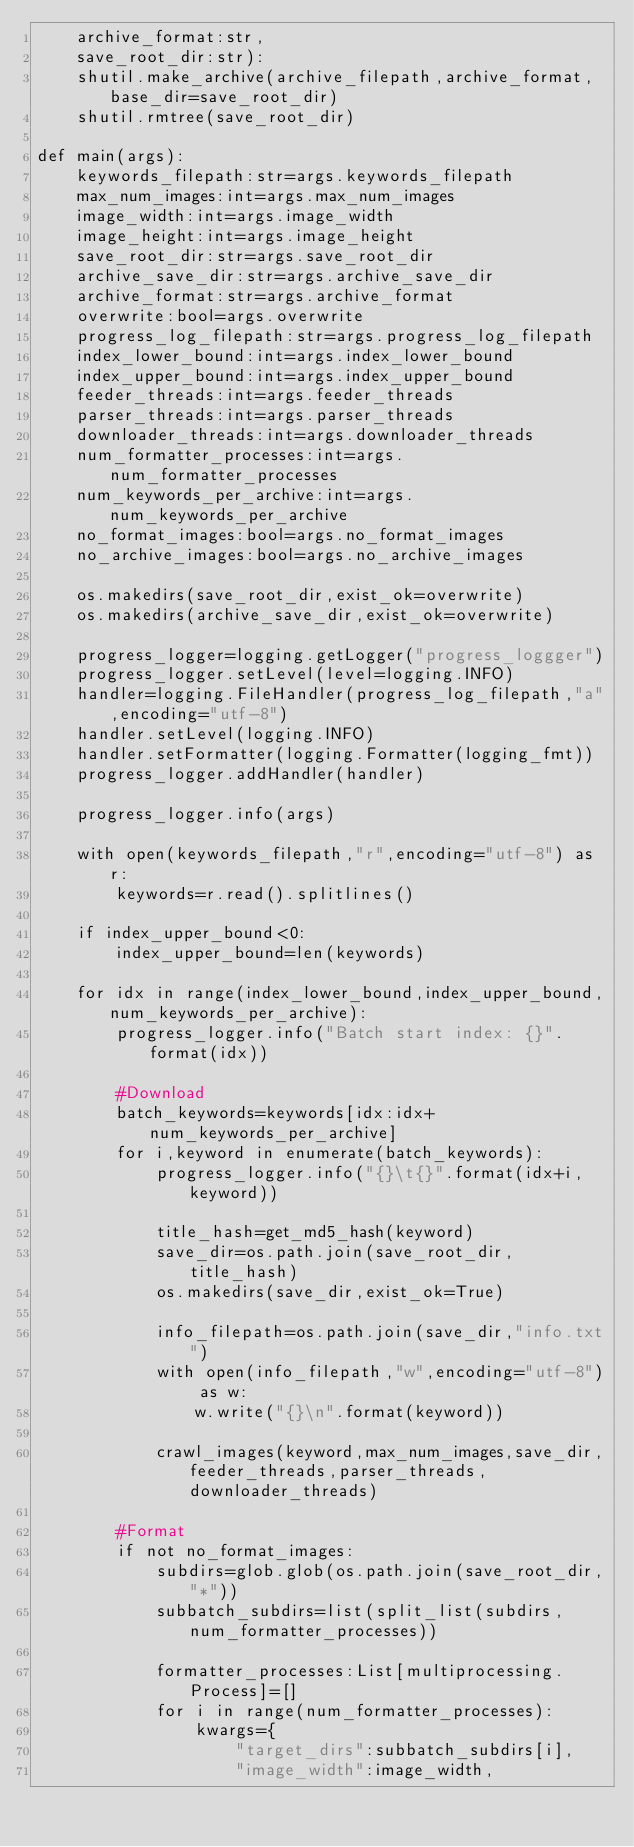Convert code to text. <code><loc_0><loc_0><loc_500><loc_500><_Python_>    archive_format:str,
    save_root_dir:str):
    shutil.make_archive(archive_filepath,archive_format,base_dir=save_root_dir)
    shutil.rmtree(save_root_dir)

def main(args):
    keywords_filepath:str=args.keywords_filepath
    max_num_images:int=args.max_num_images
    image_width:int=args.image_width
    image_height:int=args.image_height
    save_root_dir:str=args.save_root_dir
    archive_save_dir:str=args.archive_save_dir
    archive_format:str=args.archive_format
    overwrite:bool=args.overwrite
    progress_log_filepath:str=args.progress_log_filepath
    index_lower_bound:int=args.index_lower_bound
    index_upper_bound:int=args.index_upper_bound
    feeder_threads:int=args.feeder_threads
    parser_threads:int=args.parser_threads
    downloader_threads:int=args.downloader_threads
    num_formatter_processes:int=args.num_formatter_processes
    num_keywords_per_archive:int=args.num_keywords_per_archive
    no_format_images:bool=args.no_format_images
    no_archive_images:bool=args.no_archive_images

    os.makedirs(save_root_dir,exist_ok=overwrite)
    os.makedirs(archive_save_dir,exist_ok=overwrite)

    progress_logger=logging.getLogger("progress_loggger")
    progress_logger.setLevel(level=logging.INFO)
    handler=logging.FileHandler(progress_log_filepath,"a",encoding="utf-8")
    handler.setLevel(logging.INFO)
    handler.setFormatter(logging.Formatter(logging_fmt))
    progress_logger.addHandler(handler)

    progress_logger.info(args)

    with open(keywords_filepath,"r",encoding="utf-8") as r:
        keywords=r.read().splitlines()

    if index_upper_bound<0:
        index_upper_bound=len(keywords)

    for idx in range(index_lower_bound,index_upper_bound,num_keywords_per_archive):
        progress_logger.info("Batch start index: {}".format(idx))

        #Download
        batch_keywords=keywords[idx:idx+num_keywords_per_archive]
        for i,keyword in enumerate(batch_keywords):
            progress_logger.info("{}\t{}".format(idx+i,keyword))

            title_hash=get_md5_hash(keyword)
            save_dir=os.path.join(save_root_dir,title_hash)
            os.makedirs(save_dir,exist_ok=True)

            info_filepath=os.path.join(save_dir,"info.txt")
            with open(info_filepath,"w",encoding="utf-8") as w:
                w.write("{}\n".format(keyword))

            crawl_images(keyword,max_num_images,save_dir,feeder_threads,parser_threads,downloader_threads)

        #Format
        if not no_format_images:
            subdirs=glob.glob(os.path.join(save_root_dir,"*"))
            subbatch_subdirs=list(split_list(subdirs,num_formatter_processes))

            formatter_processes:List[multiprocessing.Process]=[]
            for i in range(num_formatter_processes):
                kwargs={
                    "target_dirs":subbatch_subdirs[i],
                    "image_width":image_width,</code> 